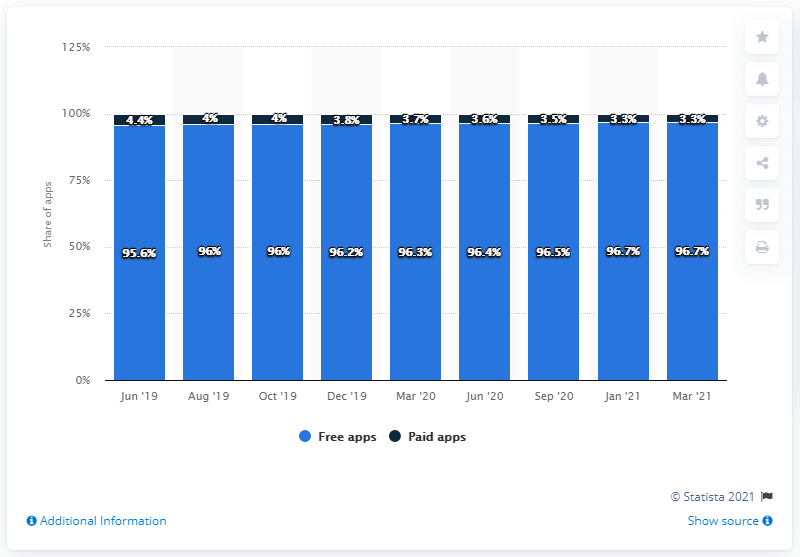Point out several critical features in this image. As of March 2021, it was reported that 96.7% of all Android applications were free. 